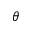<formula> <loc_0><loc_0><loc_500><loc_500>\theta</formula> 